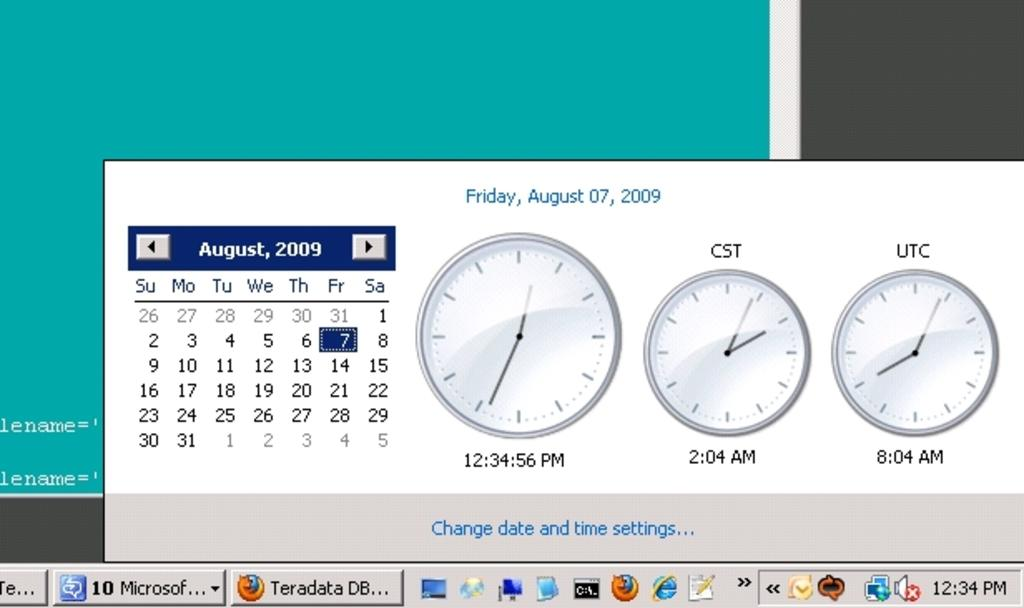<image>
Summarize the visual content of the image. A screenshot of a computer page showing a calendar from August 2009. 